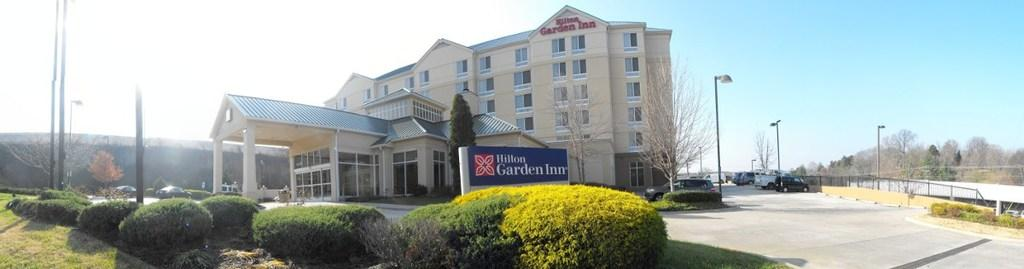What is the main feature of the image? The main feature of the image is a road. What can be seen traveling on the road? There are cars in the image. What type of vegetation is present in the image? There are plants, grass, and trees in the image. What structures are present in the image? There are poles, a board, a fence, and a building in the image. What is visible in the background of the image? The sky is visible in the background of the image. How can one join the organization of cars in the image? There is no organization of cars in the image, as they are simply traveling on the road. 